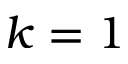<formula> <loc_0><loc_0><loc_500><loc_500>k = 1</formula> 